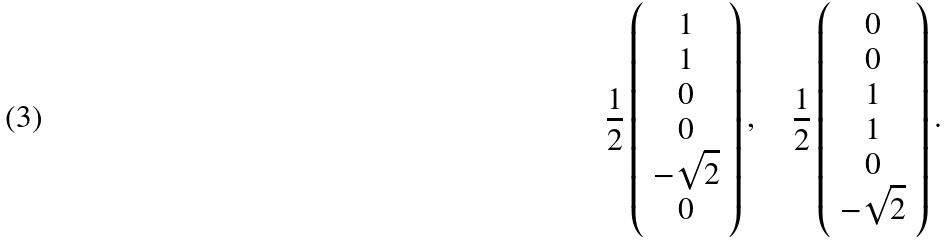<formula> <loc_0><loc_0><loc_500><loc_500>\frac { 1 } { 2 } \left ( \begin{array} { c } 1 \\ 1 \\ 0 \\ 0 \\ - \sqrt { 2 } \\ 0 \end{array} \right ) , \quad \frac { 1 } { 2 } \left ( \begin{array} { c } 0 \\ 0 \\ 1 \\ 1 \\ 0 \\ - \sqrt { 2 } \end{array} \right ) .</formula> 